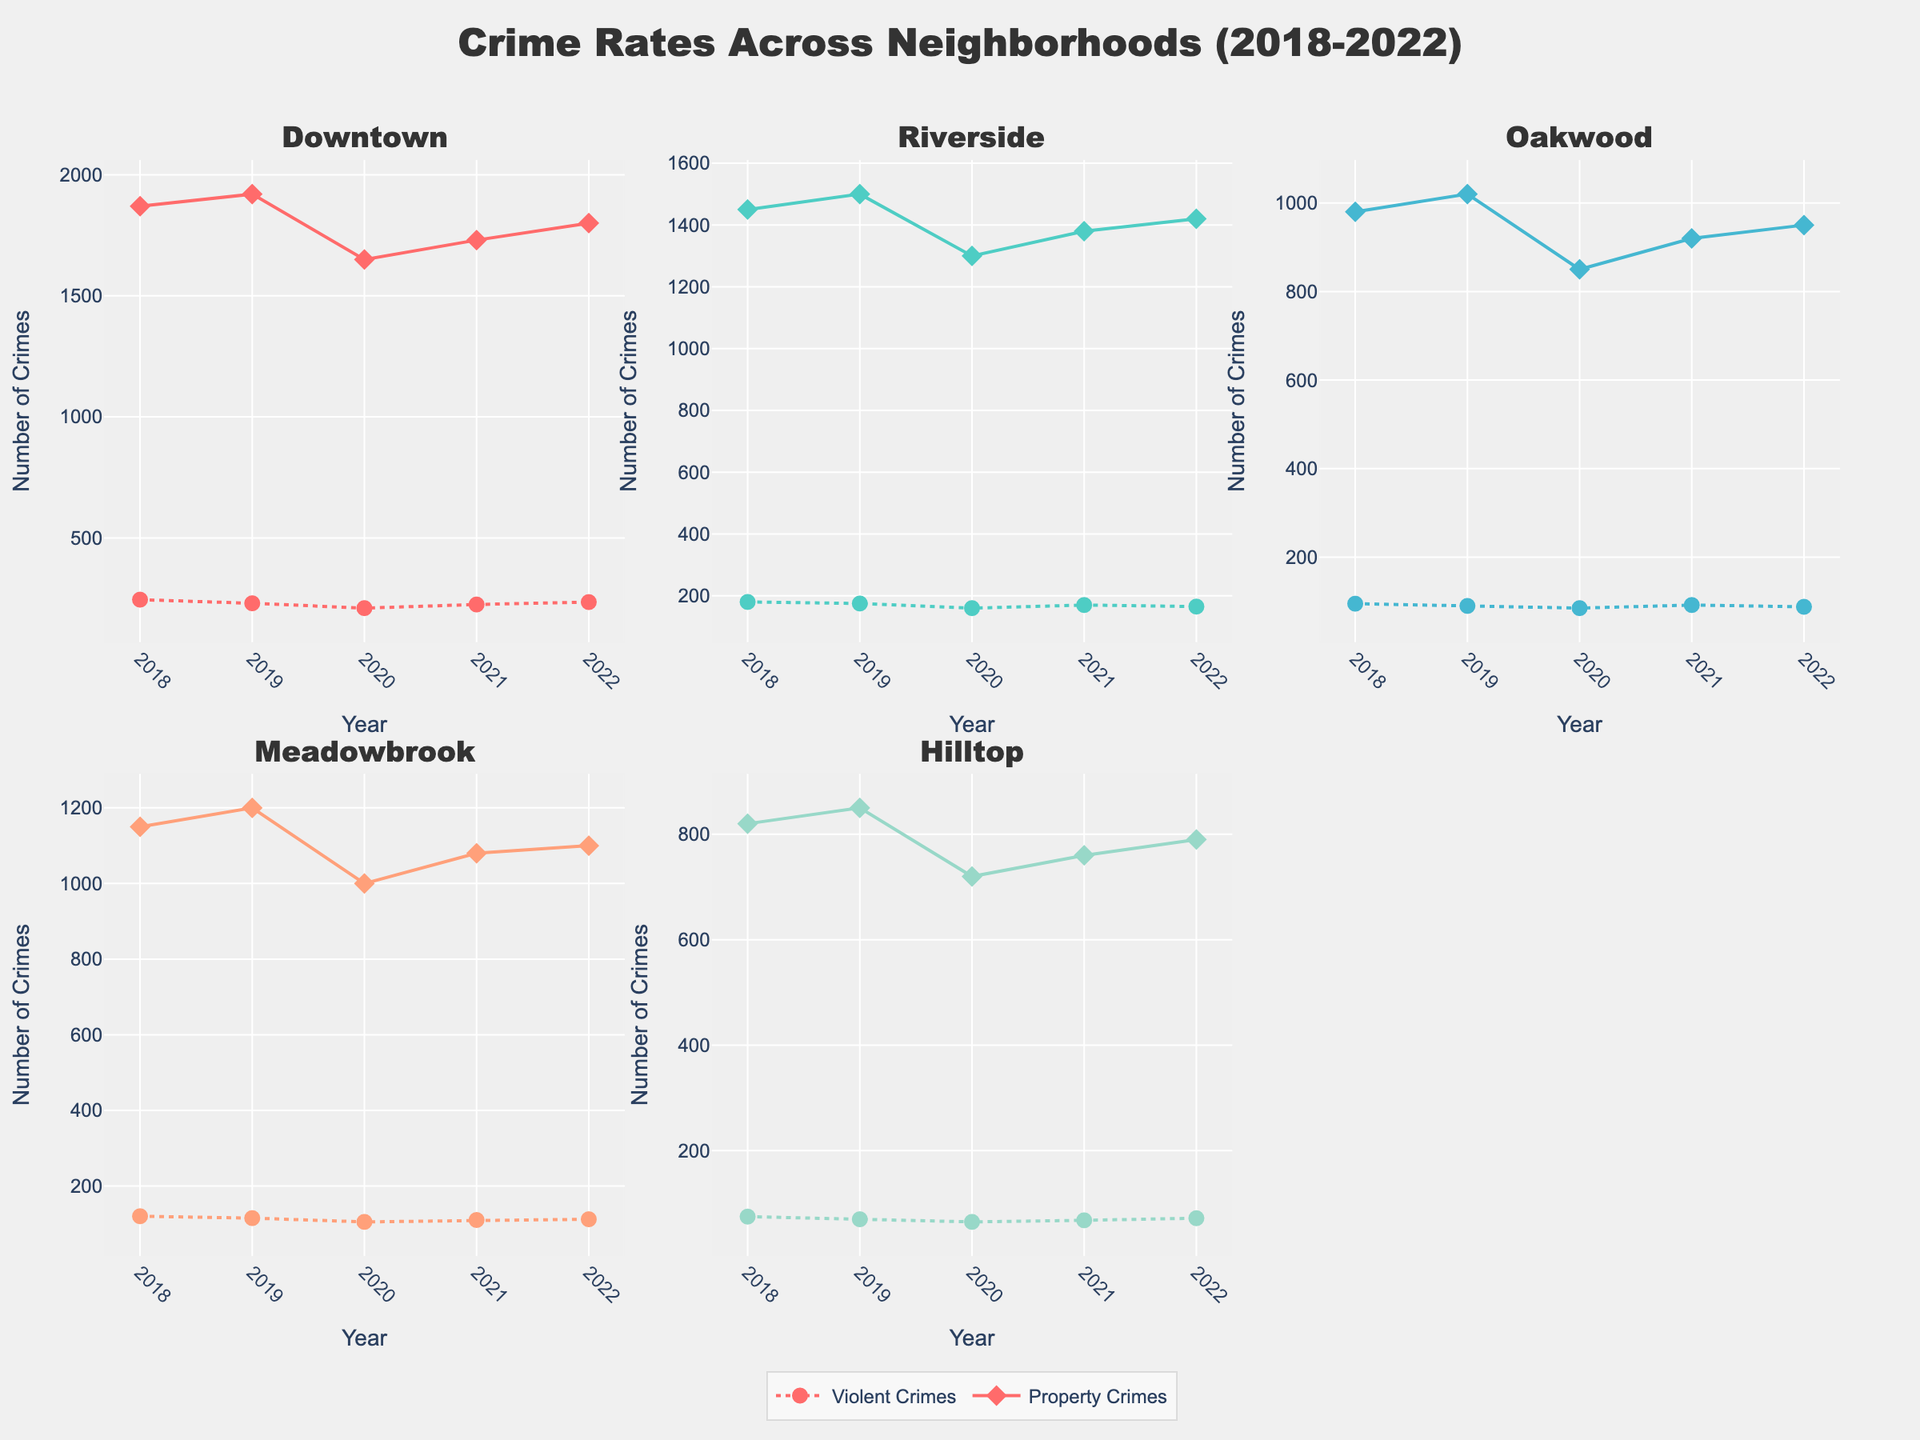How many data points are there for Instagram? Identify the scatter plot for Instagram and count the number of points. Instagram has 3 data points for distinct follower counts. Combine and count them all.
Answer: 3 Which social media platform has the highest number of followers in the data? Look at the social media scatter plots and find the data point with the largest x-axis value (followers). TikTok shows 200,000 followers.
Answer: TikTok What is the range of casting opportunities for Twitter? Go to the Twitter scatter plot and find the minimum and maximum y-axis values. The casting opportunities for Twitter range from 1 to 20.
Answer: 1 to 20 How does the trend of casting opportunities with an increase in followers compare between TikTok and Facebook? Examine the scatter plots for both platforms. TikTok shows a steeper increase in casting opportunities with more followers compared to Facebook, implying a stronger correlation.
Answer: TikTok has a stronger correlation Among the platforms, which has the smallest rate of increase in casting opportunities relative to followers? Compare the slope of increases in casting opportunities among platforms’ scatter plots. Facebook rises slowly compared to others.
Answer: Facebook What is the median number of casting opportunities for YouTube? Sort the casting opportunity values for YouTube (5, 15, 35). The median is the middle value, 15.
Answer: 15 How many platforms have a maximum of more than 10 casting opportunities? Check the highest casting opportunities on y-axes across all scatter plots: Instagram, TikTok, Twitter, YouTube exceed 10.
Answer: 4 Compare the data point with the highest followers between Instagram and YouTube. How do their casting opportunities differ? Locate the highest follower points: Instagram with ~100,000 followers and YouTube with ~150,000 followers. Instagram has 25 casting opportunities, YouTube has 35.
Answer: YouTube has 10 more Which platform has the highest data point combination of followers with the least casting opportunities? Find the platform with the highest followers but the least casting opportunities. Twitter with 50,000 followers and only 6 casting opportunities.
Answer: Twitter Is there any platform where more followers do not lead to a significant increase in casting opportunities? Compare all scatter plots for trends. Facebook data points show minimal change in opportunities with increase in followers.
Answer: Facebook 